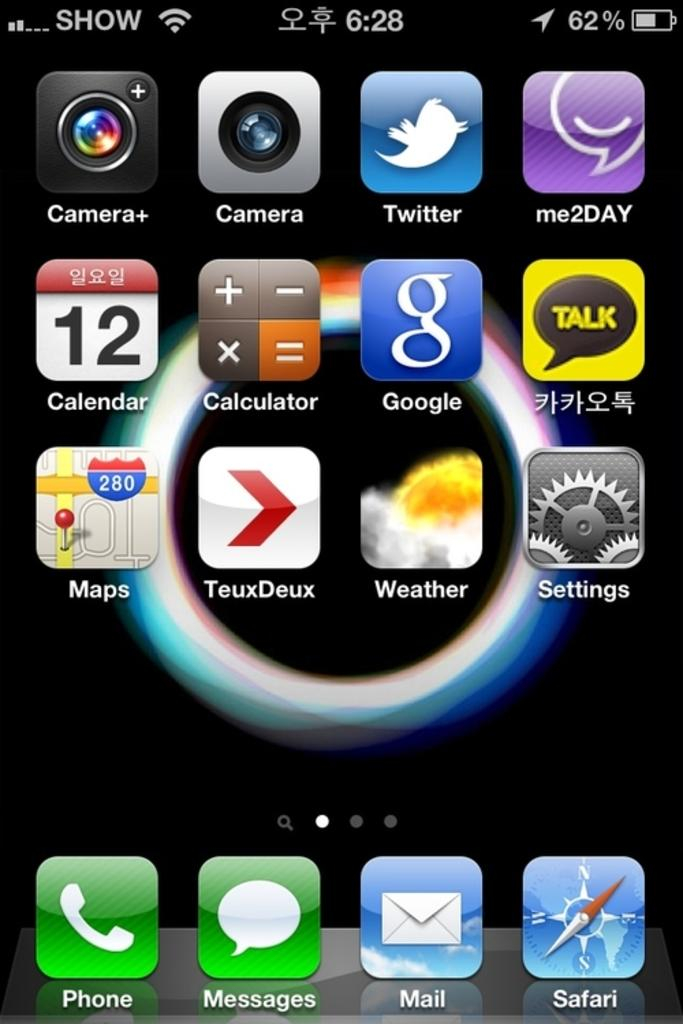Provide a one-sentence caption for the provided image. A close up of a smart phone with the first app being the phone call icon. 